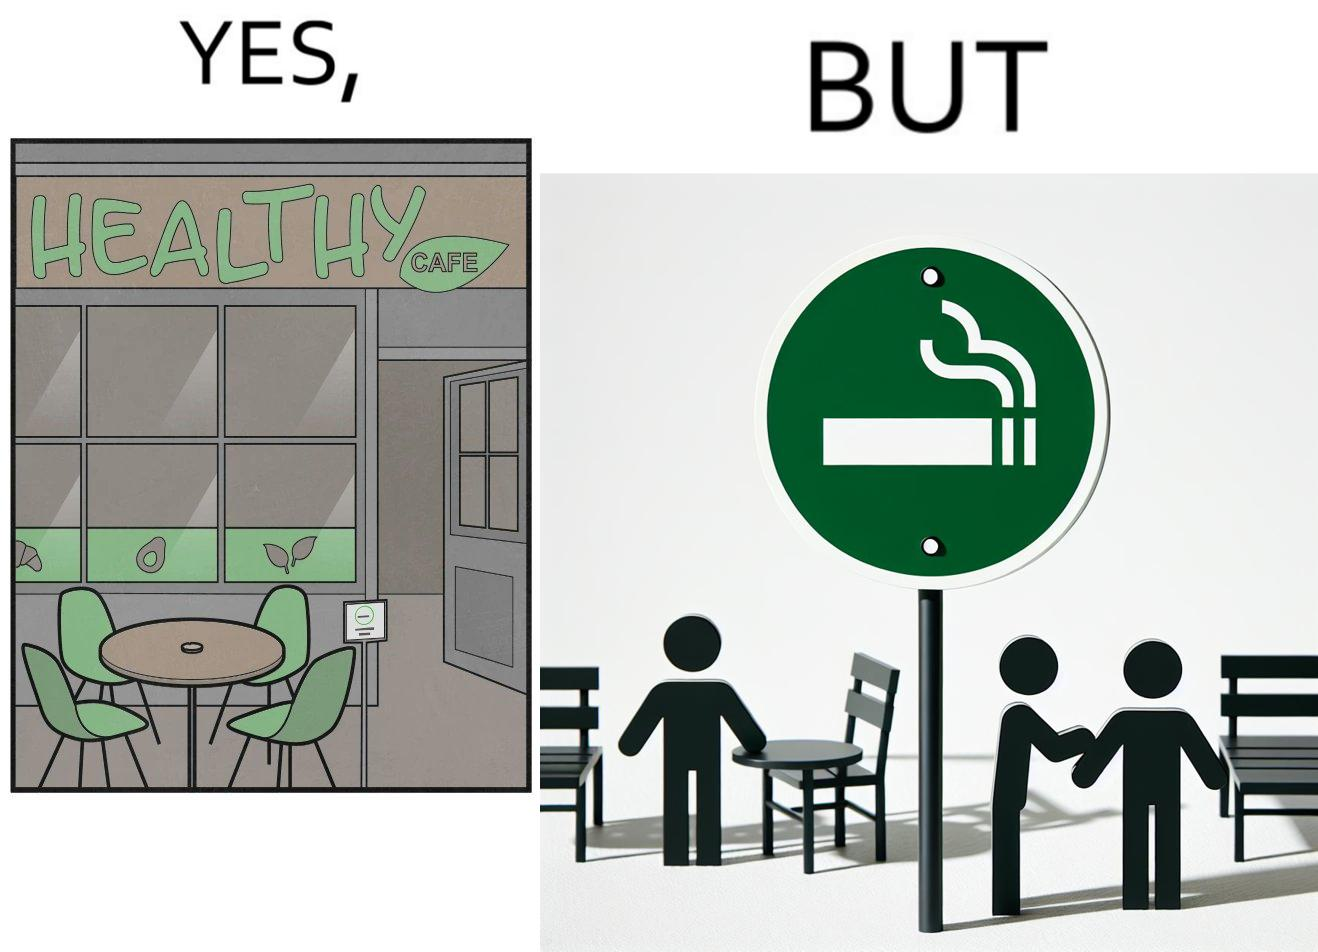Compare the left and right sides of this image. In the left part of the image: An eatery with the name "Healthy Cafe". It has a green aesthetic with paintings of leaves, avocados, etc on their windows. They have an outdoor seating area with 4 green patio chairs around a circular table. There is a small sign on a stand near the table with a green circular symbol and some text that is too small to read. In the right part of the image: Green patio chairs. A sign on a stand that has a green circular symbol encircling a cigarette symbol, and some text that says "SMOKING AREA". 